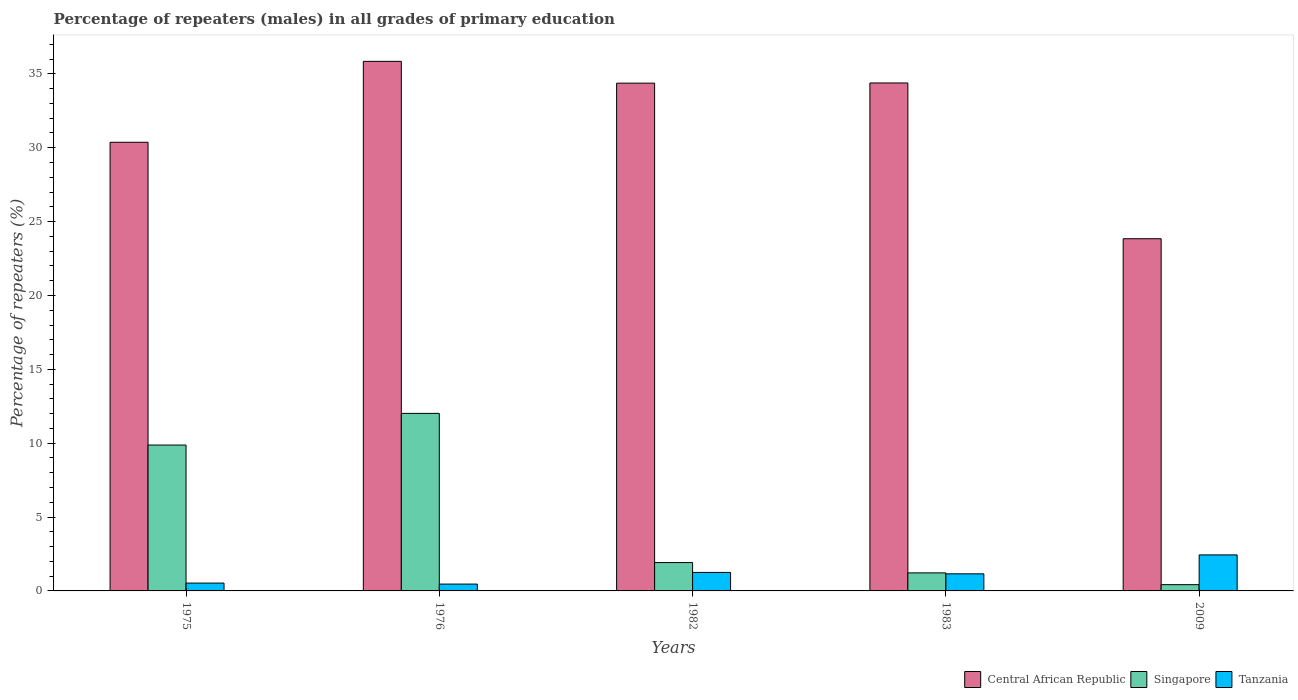How many different coloured bars are there?
Your answer should be compact. 3. Are the number of bars on each tick of the X-axis equal?
Give a very brief answer. Yes. What is the label of the 2nd group of bars from the left?
Your answer should be very brief. 1976. In how many cases, is the number of bars for a given year not equal to the number of legend labels?
Ensure brevity in your answer.  0. What is the percentage of repeaters (males) in Singapore in 1982?
Your response must be concise. 1.92. Across all years, what is the maximum percentage of repeaters (males) in Tanzania?
Offer a very short reply. 2.44. Across all years, what is the minimum percentage of repeaters (males) in Singapore?
Make the answer very short. 0.42. In which year was the percentage of repeaters (males) in Singapore maximum?
Provide a succinct answer. 1976. What is the total percentage of repeaters (males) in Tanzania in the graph?
Make the answer very short. 5.84. What is the difference between the percentage of repeaters (males) in Singapore in 1982 and that in 1983?
Give a very brief answer. 0.7. What is the difference between the percentage of repeaters (males) in Central African Republic in 1976 and the percentage of repeaters (males) in Tanzania in 2009?
Ensure brevity in your answer.  33.41. What is the average percentage of repeaters (males) in Tanzania per year?
Ensure brevity in your answer.  1.17. In the year 1982, what is the difference between the percentage of repeaters (males) in Singapore and percentage of repeaters (males) in Central African Republic?
Make the answer very short. -32.45. What is the ratio of the percentage of repeaters (males) in Singapore in 1975 to that in 1976?
Provide a short and direct response. 0.82. What is the difference between the highest and the second highest percentage of repeaters (males) in Tanzania?
Give a very brief answer. 1.19. What is the difference between the highest and the lowest percentage of repeaters (males) in Tanzania?
Ensure brevity in your answer.  1.98. In how many years, is the percentage of repeaters (males) in Singapore greater than the average percentage of repeaters (males) in Singapore taken over all years?
Keep it short and to the point. 2. What does the 3rd bar from the left in 1982 represents?
Ensure brevity in your answer.  Tanzania. What does the 2nd bar from the right in 1975 represents?
Offer a very short reply. Singapore. Is it the case that in every year, the sum of the percentage of repeaters (males) in Singapore and percentage of repeaters (males) in Central African Republic is greater than the percentage of repeaters (males) in Tanzania?
Make the answer very short. Yes. How many bars are there?
Ensure brevity in your answer.  15. Are all the bars in the graph horizontal?
Make the answer very short. No. What is the difference between two consecutive major ticks on the Y-axis?
Offer a terse response. 5. Does the graph contain any zero values?
Offer a very short reply. No. Where does the legend appear in the graph?
Offer a very short reply. Bottom right. How many legend labels are there?
Provide a succinct answer. 3. How are the legend labels stacked?
Your response must be concise. Horizontal. What is the title of the graph?
Provide a short and direct response. Percentage of repeaters (males) in all grades of primary education. What is the label or title of the Y-axis?
Provide a succinct answer. Percentage of repeaters (%). What is the Percentage of repeaters (%) of Central African Republic in 1975?
Offer a very short reply. 30.37. What is the Percentage of repeaters (%) of Singapore in 1975?
Give a very brief answer. 9.88. What is the Percentage of repeaters (%) in Tanzania in 1975?
Give a very brief answer. 0.53. What is the Percentage of repeaters (%) of Central African Republic in 1976?
Ensure brevity in your answer.  35.85. What is the Percentage of repeaters (%) of Singapore in 1976?
Give a very brief answer. 12.02. What is the Percentage of repeaters (%) of Tanzania in 1976?
Provide a succinct answer. 0.46. What is the Percentage of repeaters (%) in Central African Republic in 1982?
Keep it short and to the point. 34.37. What is the Percentage of repeaters (%) in Singapore in 1982?
Offer a very short reply. 1.92. What is the Percentage of repeaters (%) of Tanzania in 1982?
Offer a terse response. 1.25. What is the Percentage of repeaters (%) of Central African Republic in 1983?
Provide a succinct answer. 34.39. What is the Percentage of repeaters (%) in Singapore in 1983?
Offer a very short reply. 1.22. What is the Percentage of repeaters (%) in Tanzania in 1983?
Offer a terse response. 1.16. What is the Percentage of repeaters (%) in Central African Republic in 2009?
Your response must be concise. 23.84. What is the Percentage of repeaters (%) in Singapore in 2009?
Keep it short and to the point. 0.42. What is the Percentage of repeaters (%) in Tanzania in 2009?
Provide a succinct answer. 2.44. Across all years, what is the maximum Percentage of repeaters (%) in Central African Republic?
Your answer should be compact. 35.85. Across all years, what is the maximum Percentage of repeaters (%) of Singapore?
Provide a short and direct response. 12.02. Across all years, what is the maximum Percentage of repeaters (%) of Tanzania?
Your answer should be very brief. 2.44. Across all years, what is the minimum Percentage of repeaters (%) of Central African Republic?
Provide a short and direct response. 23.84. Across all years, what is the minimum Percentage of repeaters (%) of Singapore?
Give a very brief answer. 0.42. Across all years, what is the minimum Percentage of repeaters (%) of Tanzania?
Provide a short and direct response. 0.46. What is the total Percentage of repeaters (%) of Central African Republic in the graph?
Provide a short and direct response. 158.82. What is the total Percentage of repeaters (%) in Singapore in the graph?
Your answer should be compact. 25.46. What is the total Percentage of repeaters (%) in Tanzania in the graph?
Your answer should be compact. 5.84. What is the difference between the Percentage of repeaters (%) of Central African Republic in 1975 and that in 1976?
Your answer should be compact. -5.48. What is the difference between the Percentage of repeaters (%) in Singapore in 1975 and that in 1976?
Ensure brevity in your answer.  -2.14. What is the difference between the Percentage of repeaters (%) in Tanzania in 1975 and that in 1976?
Give a very brief answer. 0.07. What is the difference between the Percentage of repeaters (%) in Central African Republic in 1975 and that in 1982?
Offer a terse response. -4. What is the difference between the Percentage of repeaters (%) in Singapore in 1975 and that in 1982?
Ensure brevity in your answer.  7.96. What is the difference between the Percentage of repeaters (%) of Tanzania in 1975 and that in 1982?
Ensure brevity in your answer.  -0.72. What is the difference between the Percentage of repeaters (%) of Central African Republic in 1975 and that in 1983?
Keep it short and to the point. -4.02. What is the difference between the Percentage of repeaters (%) of Singapore in 1975 and that in 1983?
Keep it short and to the point. 8.65. What is the difference between the Percentage of repeaters (%) in Tanzania in 1975 and that in 1983?
Provide a short and direct response. -0.63. What is the difference between the Percentage of repeaters (%) of Central African Republic in 1975 and that in 2009?
Your answer should be very brief. 6.53. What is the difference between the Percentage of repeaters (%) of Singapore in 1975 and that in 2009?
Ensure brevity in your answer.  9.45. What is the difference between the Percentage of repeaters (%) of Tanzania in 1975 and that in 2009?
Ensure brevity in your answer.  -1.91. What is the difference between the Percentage of repeaters (%) of Central African Republic in 1976 and that in 1982?
Make the answer very short. 1.48. What is the difference between the Percentage of repeaters (%) of Singapore in 1976 and that in 1982?
Ensure brevity in your answer.  10.1. What is the difference between the Percentage of repeaters (%) in Tanzania in 1976 and that in 1982?
Your answer should be compact. -0.79. What is the difference between the Percentage of repeaters (%) in Central African Republic in 1976 and that in 1983?
Provide a short and direct response. 1.46. What is the difference between the Percentage of repeaters (%) of Singapore in 1976 and that in 1983?
Provide a succinct answer. 10.8. What is the difference between the Percentage of repeaters (%) in Tanzania in 1976 and that in 1983?
Provide a short and direct response. -0.69. What is the difference between the Percentage of repeaters (%) in Central African Republic in 1976 and that in 2009?
Your answer should be very brief. 12.01. What is the difference between the Percentage of repeaters (%) of Singapore in 1976 and that in 2009?
Offer a terse response. 11.6. What is the difference between the Percentage of repeaters (%) in Tanzania in 1976 and that in 2009?
Make the answer very short. -1.98. What is the difference between the Percentage of repeaters (%) of Central African Republic in 1982 and that in 1983?
Offer a terse response. -0.01. What is the difference between the Percentage of repeaters (%) in Singapore in 1982 and that in 1983?
Offer a terse response. 0.7. What is the difference between the Percentage of repeaters (%) of Tanzania in 1982 and that in 1983?
Make the answer very short. 0.1. What is the difference between the Percentage of repeaters (%) in Central African Republic in 1982 and that in 2009?
Keep it short and to the point. 10.53. What is the difference between the Percentage of repeaters (%) of Singapore in 1982 and that in 2009?
Provide a succinct answer. 1.5. What is the difference between the Percentage of repeaters (%) of Tanzania in 1982 and that in 2009?
Your response must be concise. -1.19. What is the difference between the Percentage of repeaters (%) of Central African Republic in 1983 and that in 2009?
Your response must be concise. 10.54. What is the difference between the Percentage of repeaters (%) in Singapore in 1983 and that in 2009?
Offer a very short reply. 0.8. What is the difference between the Percentage of repeaters (%) of Tanzania in 1983 and that in 2009?
Offer a terse response. -1.28. What is the difference between the Percentage of repeaters (%) in Central African Republic in 1975 and the Percentage of repeaters (%) in Singapore in 1976?
Give a very brief answer. 18.35. What is the difference between the Percentage of repeaters (%) of Central African Republic in 1975 and the Percentage of repeaters (%) of Tanzania in 1976?
Your answer should be compact. 29.91. What is the difference between the Percentage of repeaters (%) of Singapore in 1975 and the Percentage of repeaters (%) of Tanzania in 1976?
Ensure brevity in your answer.  9.41. What is the difference between the Percentage of repeaters (%) of Central African Republic in 1975 and the Percentage of repeaters (%) of Singapore in 1982?
Your answer should be compact. 28.45. What is the difference between the Percentage of repeaters (%) in Central African Republic in 1975 and the Percentage of repeaters (%) in Tanzania in 1982?
Provide a succinct answer. 29.12. What is the difference between the Percentage of repeaters (%) in Singapore in 1975 and the Percentage of repeaters (%) in Tanzania in 1982?
Provide a short and direct response. 8.62. What is the difference between the Percentage of repeaters (%) of Central African Republic in 1975 and the Percentage of repeaters (%) of Singapore in 1983?
Provide a succinct answer. 29.15. What is the difference between the Percentage of repeaters (%) in Central African Republic in 1975 and the Percentage of repeaters (%) in Tanzania in 1983?
Offer a very short reply. 29.21. What is the difference between the Percentage of repeaters (%) of Singapore in 1975 and the Percentage of repeaters (%) of Tanzania in 1983?
Offer a terse response. 8.72. What is the difference between the Percentage of repeaters (%) in Central African Republic in 1975 and the Percentage of repeaters (%) in Singapore in 2009?
Your response must be concise. 29.95. What is the difference between the Percentage of repeaters (%) of Central African Republic in 1975 and the Percentage of repeaters (%) of Tanzania in 2009?
Provide a succinct answer. 27.93. What is the difference between the Percentage of repeaters (%) in Singapore in 1975 and the Percentage of repeaters (%) in Tanzania in 2009?
Your answer should be compact. 7.44. What is the difference between the Percentage of repeaters (%) of Central African Republic in 1976 and the Percentage of repeaters (%) of Singapore in 1982?
Provide a succinct answer. 33.93. What is the difference between the Percentage of repeaters (%) in Central African Republic in 1976 and the Percentage of repeaters (%) in Tanzania in 1982?
Provide a succinct answer. 34.6. What is the difference between the Percentage of repeaters (%) of Singapore in 1976 and the Percentage of repeaters (%) of Tanzania in 1982?
Give a very brief answer. 10.77. What is the difference between the Percentage of repeaters (%) in Central African Republic in 1976 and the Percentage of repeaters (%) in Singapore in 1983?
Keep it short and to the point. 34.63. What is the difference between the Percentage of repeaters (%) in Central African Republic in 1976 and the Percentage of repeaters (%) in Tanzania in 1983?
Give a very brief answer. 34.69. What is the difference between the Percentage of repeaters (%) in Singapore in 1976 and the Percentage of repeaters (%) in Tanzania in 1983?
Give a very brief answer. 10.86. What is the difference between the Percentage of repeaters (%) in Central African Republic in 1976 and the Percentage of repeaters (%) in Singapore in 2009?
Offer a terse response. 35.43. What is the difference between the Percentage of repeaters (%) in Central African Republic in 1976 and the Percentage of repeaters (%) in Tanzania in 2009?
Keep it short and to the point. 33.41. What is the difference between the Percentage of repeaters (%) of Singapore in 1976 and the Percentage of repeaters (%) of Tanzania in 2009?
Offer a terse response. 9.58. What is the difference between the Percentage of repeaters (%) of Central African Republic in 1982 and the Percentage of repeaters (%) of Singapore in 1983?
Your answer should be very brief. 33.15. What is the difference between the Percentage of repeaters (%) in Central African Republic in 1982 and the Percentage of repeaters (%) in Tanzania in 1983?
Give a very brief answer. 33.22. What is the difference between the Percentage of repeaters (%) in Singapore in 1982 and the Percentage of repeaters (%) in Tanzania in 1983?
Provide a succinct answer. 0.76. What is the difference between the Percentage of repeaters (%) of Central African Republic in 1982 and the Percentage of repeaters (%) of Singapore in 2009?
Provide a short and direct response. 33.95. What is the difference between the Percentage of repeaters (%) of Central African Republic in 1982 and the Percentage of repeaters (%) of Tanzania in 2009?
Offer a terse response. 31.94. What is the difference between the Percentage of repeaters (%) in Singapore in 1982 and the Percentage of repeaters (%) in Tanzania in 2009?
Make the answer very short. -0.52. What is the difference between the Percentage of repeaters (%) in Central African Republic in 1983 and the Percentage of repeaters (%) in Singapore in 2009?
Make the answer very short. 33.96. What is the difference between the Percentage of repeaters (%) in Central African Republic in 1983 and the Percentage of repeaters (%) in Tanzania in 2009?
Make the answer very short. 31.95. What is the difference between the Percentage of repeaters (%) of Singapore in 1983 and the Percentage of repeaters (%) of Tanzania in 2009?
Keep it short and to the point. -1.22. What is the average Percentage of repeaters (%) in Central African Republic per year?
Offer a terse response. 31.77. What is the average Percentage of repeaters (%) in Singapore per year?
Provide a succinct answer. 5.09. What is the average Percentage of repeaters (%) in Tanzania per year?
Provide a succinct answer. 1.17. In the year 1975, what is the difference between the Percentage of repeaters (%) in Central African Republic and Percentage of repeaters (%) in Singapore?
Make the answer very short. 20.5. In the year 1975, what is the difference between the Percentage of repeaters (%) of Central African Republic and Percentage of repeaters (%) of Tanzania?
Make the answer very short. 29.84. In the year 1975, what is the difference between the Percentage of repeaters (%) in Singapore and Percentage of repeaters (%) in Tanzania?
Keep it short and to the point. 9.35. In the year 1976, what is the difference between the Percentage of repeaters (%) in Central African Republic and Percentage of repeaters (%) in Singapore?
Offer a terse response. 23.83. In the year 1976, what is the difference between the Percentage of repeaters (%) in Central African Republic and Percentage of repeaters (%) in Tanzania?
Provide a short and direct response. 35.39. In the year 1976, what is the difference between the Percentage of repeaters (%) in Singapore and Percentage of repeaters (%) in Tanzania?
Your answer should be compact. 11.56. In the year 1982, what is the difference between the Percentage of repeaters (%) of Central African Republic and Percentage of repeaters (%) of Singapore?
Your answer should be compact. 32.45. In the year 1982, what is the difference between the Percentage of repeaters (%) of Central African Republic and Percentage of repeaters (%) of Tanzania?
Ensure brevity in your answer.  33.12. In the year 1982, what is the difference between the Percentage of repeaters (%) in Singapore and Percentage of repeaters (%) in Tanzania?
Offer a terse response. 0.67. In the year 1983, what is the difference between the Percentage of repeaters (%) in Central African Republic and Percentage of repeaters (%) in Singapore?
Provide a succinct answer. 33.17. In the year 1983, what is the difference between the Percentage of repeaters (%) in Central African Republic and Percentage of repeaters (%) in Tanzania?
Offer a very short reply. 33.23. In the year 1983, what is the difference between the Percentage of repeaters (%) of Singapore and Percentage of repeaters (%) of Tanzania?
Ensure brevity in your answer.  0.06. In the year 2009, what is the difference between the Percentage of repeaters (%) of Central African Republic and Percentage of repeaters (%) of Singapore?
Provide a succinct answer. 23.42. In the year 2009, what is the difference between the Percentage of repeaters (%) in Central African Republic and Percentage of repeaters (%) in Tanzania?
Make the answer very short. 21.4. In the year 2009, what is the difference between the Percentage of repeaters (%) in Singapore and Percentage of repeaters (%) in Tanzania?
Make the answer very short. -2.02. What is the ratio of the Percentage of repeaters (%) of Central African Republic in 1975 to that in 1976?
Ensure brevity in your answer.  0.85. What is the ratio of the Percentage of repeaters (%) of Singapore in 1975 to that in 1976?
Offer a terse response. 0.82. What is the ratio of the Percentage of repeaters (%) in Tanzania in 1975 to that in 1976?
Make the answer very short. 1.14. What is the ratio of the Percentage of repeaters (%) of Central African Republic in 1975 to that in 1982?
Your answer should be very brief. 0.88. What is the ratio of the Percentage of repeaters (%) in Singapore in 1975 to that in 1982?
Make the answer very short. 5.14. What is the ratio of the Percentage of repeaters (%) in Tanzania in 1975 to that in 1982?
Offer a very short reply. 0.42. What is the ratio of the Percentage of repeaters (%) of Central African Republic in 1975 to that in 1983?
Give a very brief answer. 0.88. What is the ratio of the Percentage of repeaters (%) of Singapore in 1975 to that in 1983?
Provide a short and direct response. 8.09. What is the ratio of the Percentage of repeaters (%) in Tanzania in 1975 to that in 1983?
Make the answer very short. 0.46. What is the ratio of the Percentage of repeaters (%) in Central African Republic in 1975 to that in 2009?
Give a very brief answer. 1.27. What is the ratio of the Percentage of repeaters (%) in Singapore in 1975 to that in 2009?
Give a very brief answer. 23.34. What is the ratio of the Percentage of repeaters (%) in Tanzania in 1975 to that in 2009?
Provide a succinct answer. 0.22. What is the ratio of the Percentage of repeaters (%) of Central African Republic in 1976 to that in 1982?
Offer a very short reply. 1.04. What is the ratio of the Percentage of repeaters (%) in Singapore in 1976 to that in 1982?
Your answer should be very brief. 6.26. What is the ratio of the Percentage of repeaters (%) of Tanzania in 1976 to that in 1982?
Your answer should be very brief. 0.37. What is the ratio of the Percentage of repeaters (%) in Central African Republic in 1976 to that in 1983?
Your response must be concise. 1.04. What is the ratio of the Percentage of repeaters (%) in Singapore in 1976 to that in 1983?
Offer a very short reply. 9.84. What is the ratio of the Percentage of repeaters (%) in Tanzania in 1976 to that in 1983?
Provide a succinct answer. 0.4. What is the ratio of the Percentage of repeaters (%) of Central African Republic in 1976 to that in 2009?
Your response must be concise. 1.5. What is the ratio of the Percentage of repeaters (%) of Singapore in 1976 to that in 2009?
Offer a very short reply. 28.4. What is the ratio of the Percentage of repeaters (%) of Tanzania in 1976 to that in 2009?
Provide a succinct answer. 0.19. What is the ratio of the Percentage of repeaters (%) in Singapore in 1982 to that in 1983?
Your answer should be compact. 1.57. What is the ratio of the Percentage of repeaters (%) of Tanzania in 1982 to that in 1983?
Your answer should be very brief. 1.08. What is the ratio of the Percentage of repeaters (%) of Central African Republic in 1982 to that in 2009?
Provide a succinct answer. 1.44. What is the ratio of the Percentage of repeaters (%) in Singapore in 1982 to that in 2009?
Your answer should be very brief. 4.54. What is the ratio of the Percentage of repeaters (%) in Tanzania in 1982 to that in 2009?
Your response must be concise. 0.51. What is the ratio of the Percentage of repeaters (%) in Central African Republic in 1983 to that in 2009?
Your answer should be very brief. 1.44. What is the ratio of the Percentage of repeaters (%) of Singapore in 1983 to that in 2009?
Keep it short and to the point. 2.89. What is the ratio of the Percentage of repeaters (%) of Tanzania in 1983 to that in 2009?
Your response must be concise. 0.47. What is the difference between the highest and the second highest Percentage of repeaters (%) in Central African Republic?
Your answer should be compact. 1.46. What is the difference between the highest and the second highest Percentage of repeaters (%) of Singapore?
Your response must be concise. 2.14. What is the difference between the highest and the second highest Percentage of repeaters (%) of Tanzania?
Keep it short and to the point. 1.19. What is the difference between the highest and the lowest Percentage of repeaters (%) in Central African Republic?
Ensure brevity in your answer.  12.01. What is the difference between the highest and the lowest Percentage of repeaters (%) of Singapore?
Provide a succinct answer. 11.6. What is the difference between the highest and the lowest Percentage of repeaters (%) in Tanzania?
Your response must be concise. 1.98. 